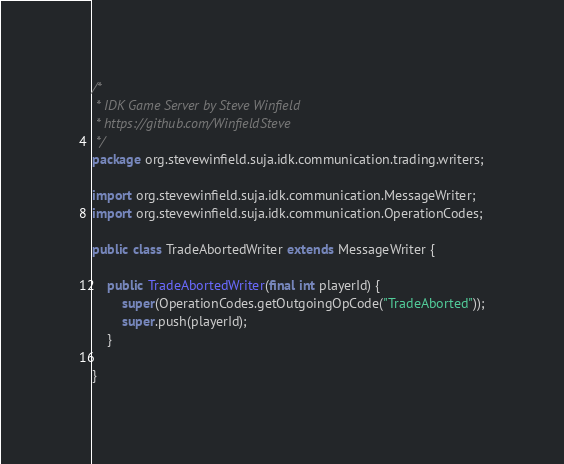<code> <loc_0><loc_0><loc_500><loc_500><_Java_>/*
 * IDK Game Server by Steve Winfield
 * https://github.com/WinfieldSteve
 */
package org.stevewinfield.suja.idk.communication.trading.writers;

import org.stevewinfield.suja.idk.communication.MessageWriter;
import org.stevewinfield.suja.idk.communication.OperationCodes;

public class TradeAbortedWriter extends MessageWriter {

    public TradeAbortedWriter(final int playerId) {
        super(OperationCodes.getOutgoingOpCode("TradeAborted"));
        super.push(playerId);
    }

}
</code> 